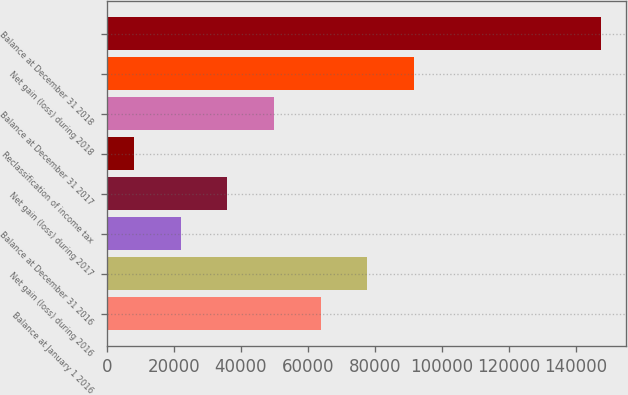<chart> <loc_0><loc_0><loc_500><loc_500><bar_chart><fcel>Balance at January 1 2016<fcel>Net gain (loss) during 2016<fcel>Balance at December 31 2016<fcel>Net gain (loss) during 2017<fcel>Reclassification of income tax<fcel>Balance at December 31 2017<fcel>Net gain (loss) during 2018<fcel>Balance at December 31 2018<nl><fcel>63849.4<fcel>77795.5<fcel>22011.1<fcel>35957.2<fcel>8065<fcel>49903.3<fcel>91741.6<fcel>147526<nl></chart> 